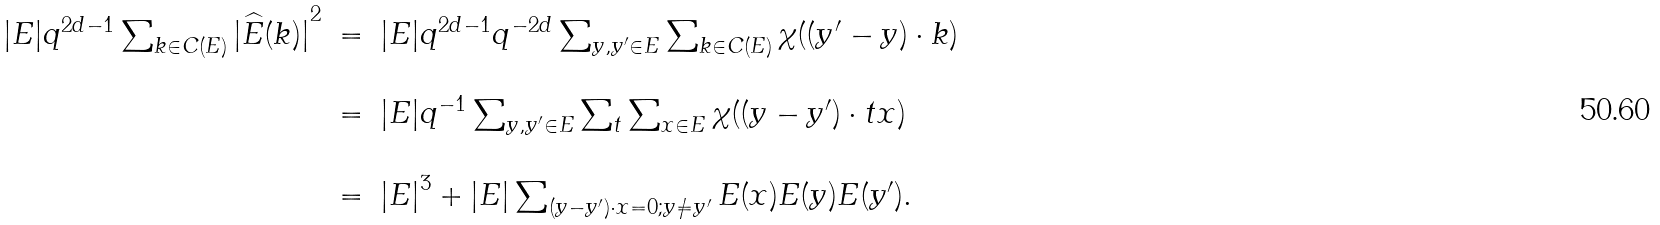<formula> <loc_0><loc_0><loc_500><loc_500>\begin{array} { l l l } | E | q ^ { 2 d - 1 } \sum _ { k \in C ( E ) } { | \widehat { E } ( k ) | } ^ { 2 } & = & | E | q ^ { 2 d - 1 } q ^ { - 2 d } \sum _ { y , y ^ { \prime } \in E } \sum _ { k \in C ( E ) } \chi ( ( y ^ { \prime } - y ) \cdot k ) \\ \\ & = & | E | q ^ { - 1 } \sum _ { y , y ^ { \prime } \in E } \sum _ { t } \sum _ { x \in E } \chi ( ( y - y ^ { \prime } ) \cdot t x ) $ $ \\ \\ & = & { | E | } ^ { 3 } + | E | \sum _ { ( y - y ^ { \prime } ) \cdot x = 0 ; y \not = y ^ { \prime } } E ( x ) E ( y ) E ( y ^ { \prime } ) . \end{array}</formula> 